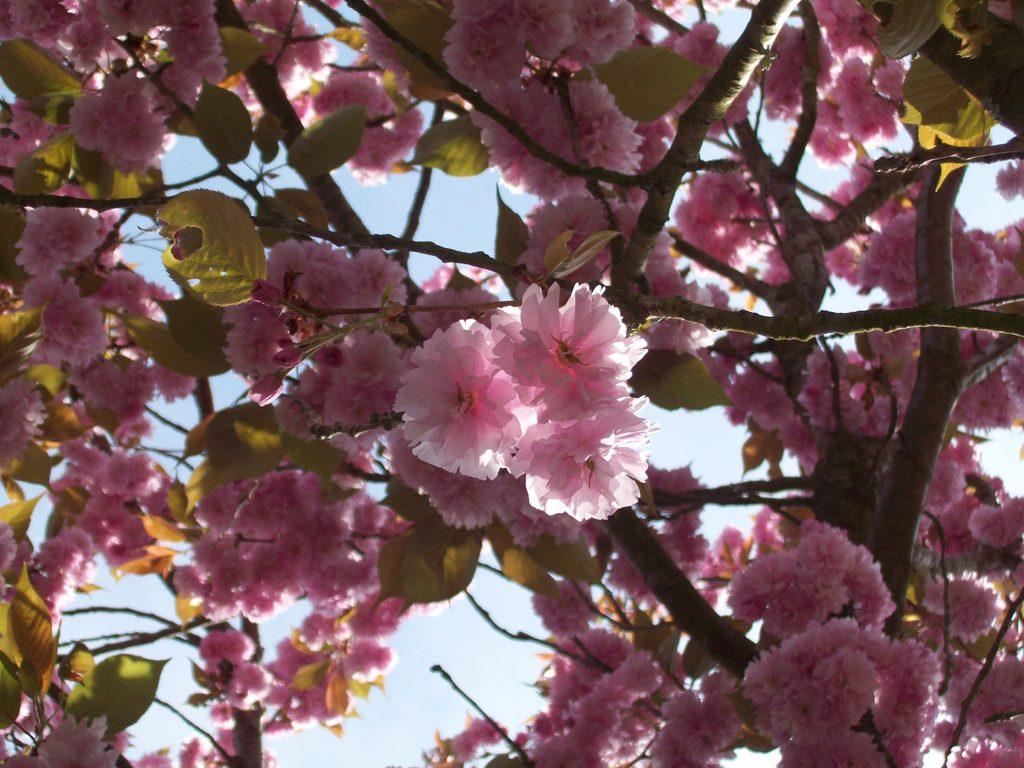What is present in the image? There is a tree in the image. What can be observed about the tree? The tree has pink color flowers. What else can be seen in the image besides the tree? There is sky visible in the image. How many beads are hanging from the tree in the image? There are no beads present in the image; it only features a tree with pink flowers. What type of corn can be seen growing near the tree in the image? There is no corn present in the image; it only features a tree with pink flowers and sky visible in the background. 